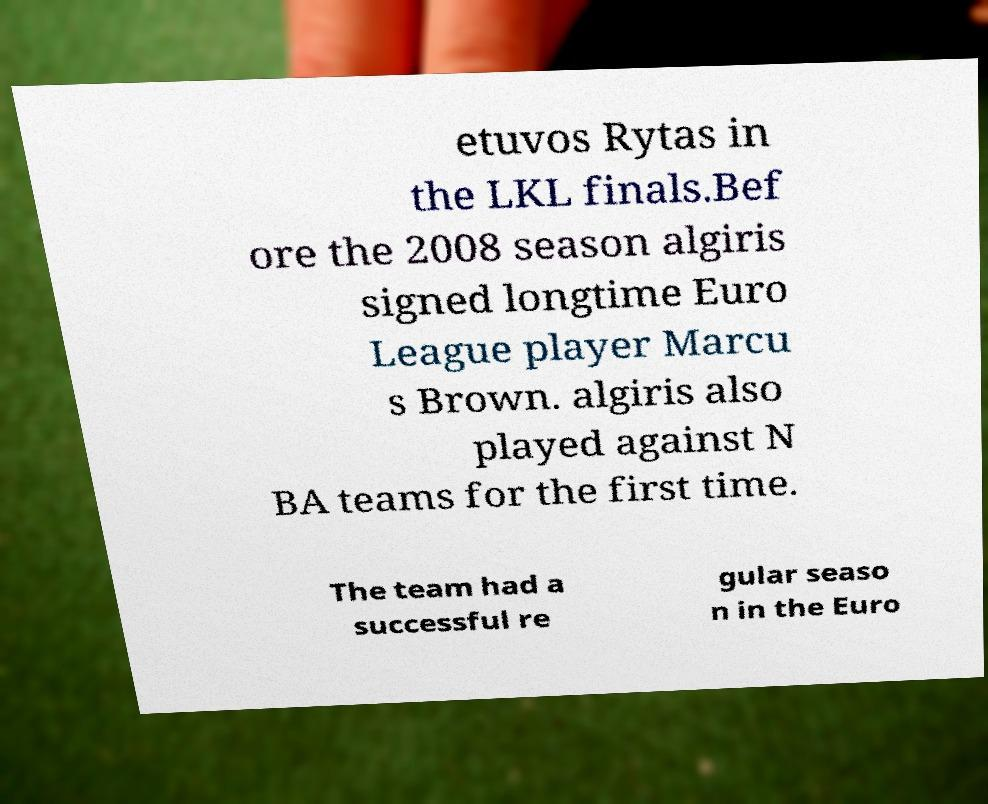Can you accurately transcribe the text from the provided image for me? etuvos Rytas in the LKL finals.Bef ore the 2008 season algiris signed longtime Euro League player Marcu s Brown. algiris also played against N BA teams for the first time. The team had a successful re gular seaso n in the Euro 